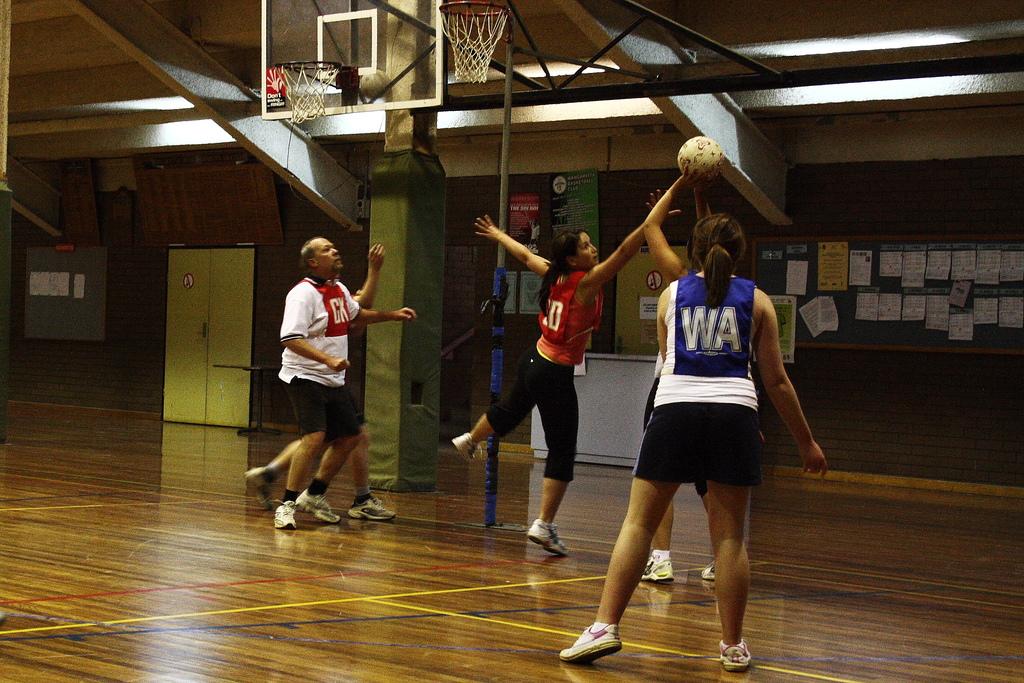What team is in blue?
Make the answer very short. Wa. What number is the girl in red?
Your response must be concise. 10. 